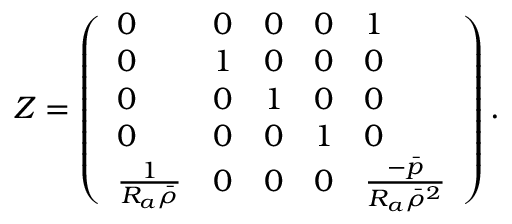Convert formula to latex. <formula><loc_0><loc_0><loc_500><loc_500>Z = \left ( \begin{array} { l l l l l } { 0 } & { 0 } & { 0 } & { 0 } & { 1 } \\ { 0 } & { 1 } & { 0 } & { 0 } & { 0 } \\ { 0 } & { 0 } & { 1 } & { 0 } & { 0 } \\ { 0 } & { 0 } & { 0 } & { 1 } & { 0 } \\ { \frac { 1 } { R _ { a } \bar { \rho } } } & { 0 } & { 0 } & { 0 } & { \frac { - \bar { p } } { R _ { a } \bar { \rho } ^ { 2 } } } \end{array} \right ) .</formula> 